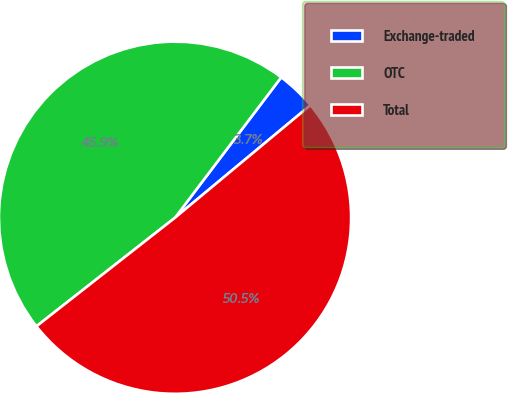<chart> <loc_0><loc_0><loc_500><loc_500><pie_chart><fcel>Exchange-traded<fcel>OTC<fcel>Total<nl><fcel>3.66%<fcel>45.88%<fcel>50.46%<nl></chart> 